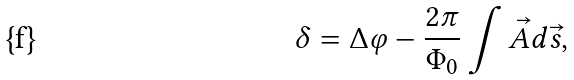Convert formula to latex. <formula><loc_0><loc_0><loc_500><loc_500>\delta = \Delta \varphi - \frac { 2 \pi } { \Phi _ { 0 } } \int \vec { A } d \vec { s } ,</formula> 